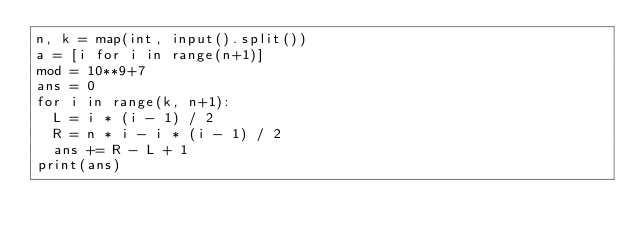Convert code to text. <code><loc_0><loc_0><loc_500><loc_500><_Python_>n, k = map(int, input().split())
a = [i for i in range(n+1)]
mod = 10**9+7
ans = 0
for i in range(k, n+1):
  L = i * (i - 1) / 2
  R = n * i - i * (i - 1) / 2
  ans += R - L + 1
print(ans)</code> 